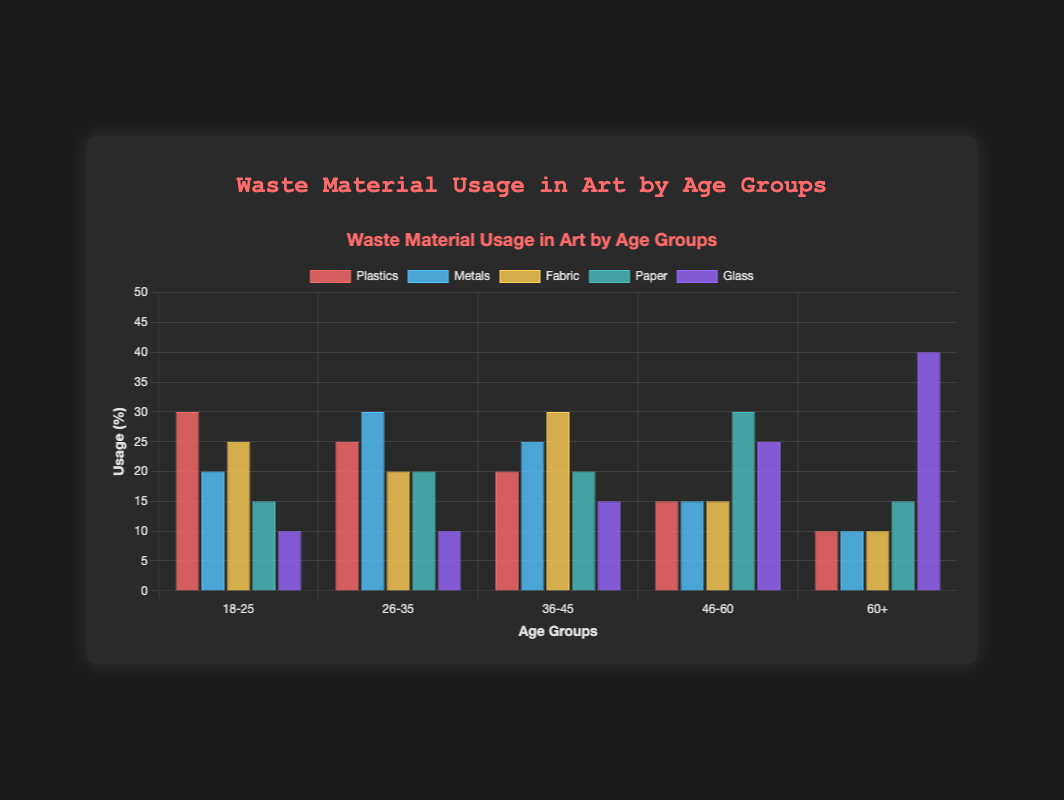What's the most used material by the 18-25 age group? Look at the bar values for the 18-25 age group across all materials. Plastics have the highest value at 30%.
Answer: Plastics Which age group uses Glass the most? Compare the bar heights for Glass across all age groups. The 60+ group has the highest usage at 40%.
Answer: 60+ What is the total usage of Fabric across all age groups? Sum the usage of Fabric across all age groups: 25% + 20% + 30% + 15% + 10% = 100%.
Answer: 100% Which material is least used by the 46-60 age group? Look at the bar values for the 46-60 age group across all materials. Plastics, Metals, and Fabric all have the lowest value at 15%.
Answer: Plastics, Metals, Fabric How does the usage of Paper by the 26-35 age group compare to the 36-45 age group? Look at the bar heights for Paper in the 26-35 and 36-45 age groups. Both have the same usage value of 20%.
Answer: Equal Does the 60+ age group use more Metal or Paper? Compare the bar heights for Metal and Paper in the 60+ age group. Metal is 10% and Paper is 15%, so they use more Paper.
Answer: Paper What is the difference in the usage of Plastics between the 18-25 and 46-60 age groups? Subtract the usage of Plastics in the 46-60 age group from that in the 18-25 age group: 30% - 15% = 15%.
Answer: 15% What is the average usage of Metals across all age groups? Sum the usage of Metals across all age groups and divide by the number of groups: (20% + 30% + 25% + 15% + 10%) / 5 = 20%.
Answer: 20% Which material is used equally by the 60+ and 46-60 age groups? Look for bars of equal height for the 60+ and 46-60 age groups. Paper has equal heights of 15%.
Answer: Paper Which age group uses Fabric the most? Compare the bar heights for Fabric across all age groups. The 36-45 age group has the highest usage at 30%.
Answer: 36-45 